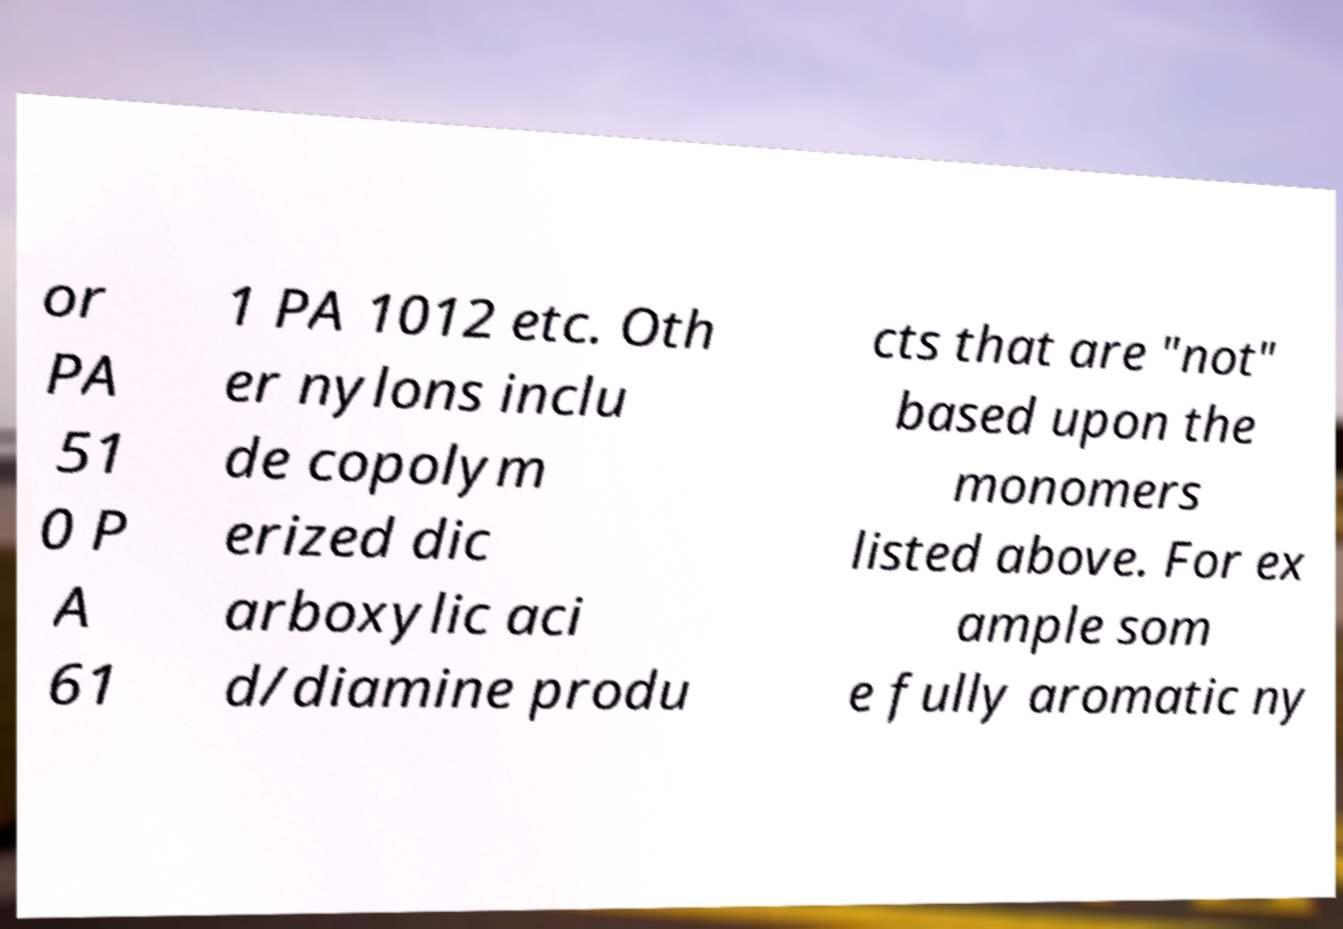I need the written content from this picture converted into text. Can you do that? or PA 51 0 P A 61 1 PA 1012 etc. Oth er nylons inclu de copolym erized dic arboxylic aci d/diamine produ cts that are "not" based upon the monomers listed above. For ex ample som e fully aromatic ny 